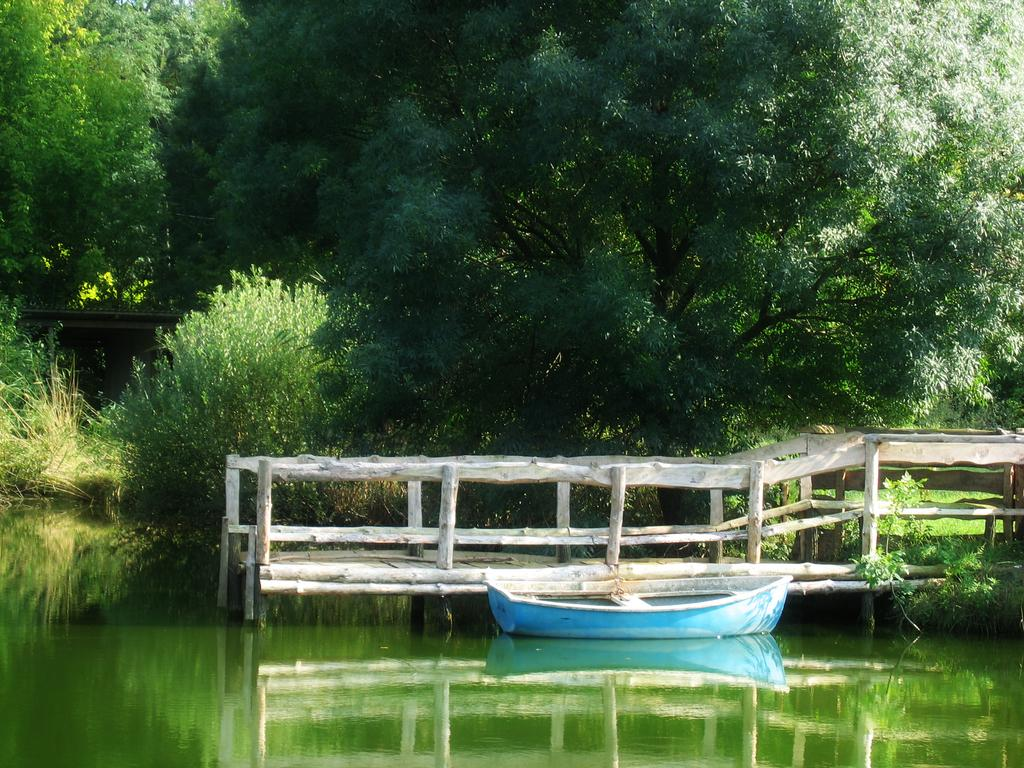What is the main feature of the image? There is water in the image. What is floating on the water? There is a boat in the image. What can be seen near the water's edge? There is railing in the image. What type of vegetation is present in the image? There are plants and trees in the image. Where is the hole in the image? There is no hole present in the image. What type of comb is used to groom the plants in the image? There is no comb present in the image, and plants do not require grooming with a comb. 